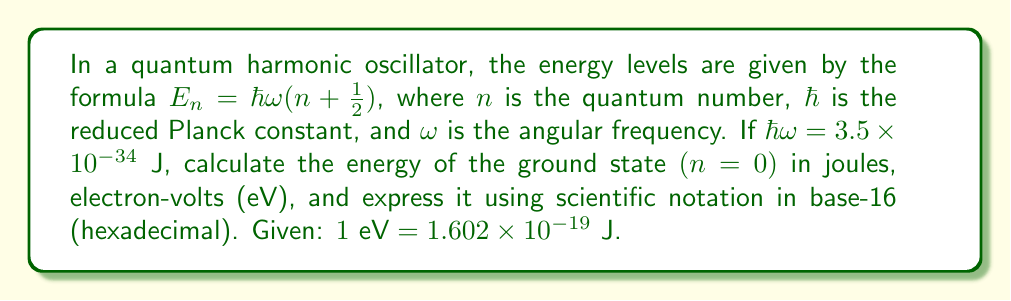Can you answer this question? Let's approach this step-by-step:

1) First, let's calculate the energy in joules:
   $$E_0 = \hbar\omega(0 + \frac{1}{2}) = \frac{1}{2}\hbar\omega$$
   $$E_0 = \frac{1}{2}(3.5 \times 10^{-34}) = 1.75 \times 10^{-34} \text{ J}$$

2) Now, let's convert this to electron-volts:
   $$E_0 \text{ (in eV)} = \frac{1.75 \times 10^{-34} \text{ J}}{1.602 \times 10^{-19} \text{ J/eV}} = 1.092 \times 10^{-15} \text{ eV}$$

3) To express this in hexadecimal scientific notation, we first convert the decimal to hexadecimal:
   $1.75 \times 10^{-34}$ in decimal is equivalent to $1.C \times 16^{-2D}$ in hexadecimal.

   Here's how we arrived at this:
   - The significand 1.75 in decimal is 1.C in hexadecimal
   - The exponent -34 in decimal is -2D in hexadecimal (because $-34_{10} = -2D_{16}$)

Thus, we have represented the energy in three different numerical systems: decimal, scientific notation with base 10, and scientific notation with base 16.
Answer: $1.75 \times 10^{-34}$ J, $1.092 \times 10^{-15}$ eV, $1.C \times 16^{-2D}$ J 